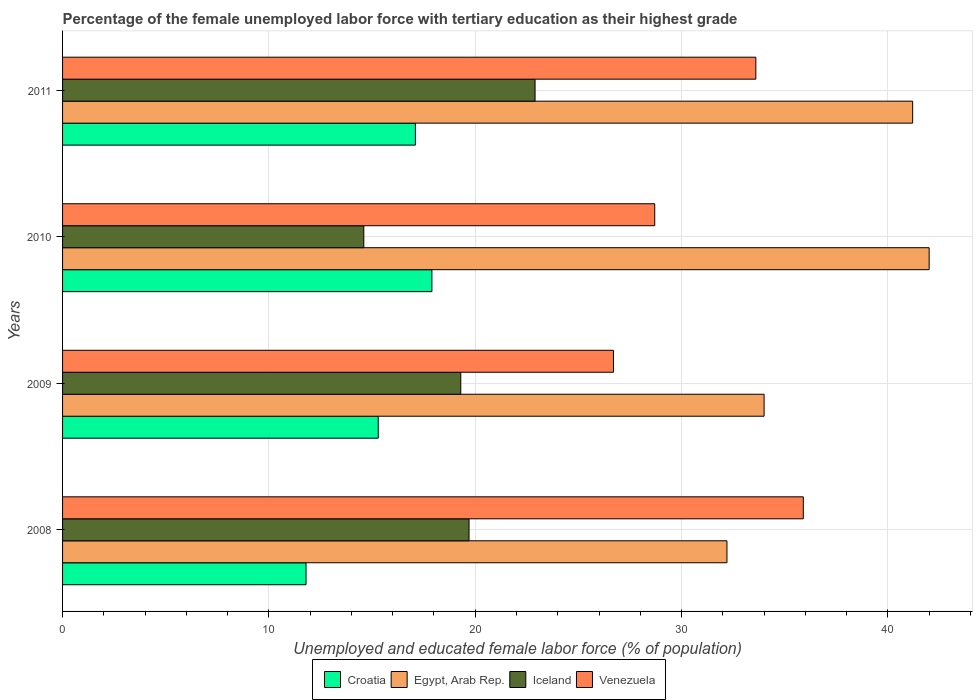Are the number of bars on each tick of the Y-axis equal?
Ensure brevity in your answer.  Yes. How many bars are there on the 2nd tick from the bottom?
Make the answer very short. 4. What is the label of the 4th group of bars from the top?
Offer a terse response. 2008. What is the percentage of the unemployed female labor force with tertiary education in Egypt, Arab Rep. in 2008?
Your response must be concise. 32.2. Across all years, what is the maximum percentage of the unemployed female labor force with tertiary education in Egypt, Arab Rep.?
Your response must be concise. 42. Across all years, what is the minimum percentage of the unemployed female labor force with tertiary education in Croatia?
Offer a very short reply. 11.8. In which year was the percentage of the unemployed female labor force with tertiary education in Egypt, Arab Rep. maximum?
Provide a short and direct response. 2010. In which year was the percentage of the unemployed female labor force with tertiary education in Egypt, Arab Rep. minimum?
Provide a succinct answer. 2008. What is the total percentage of the unemployed female labor force with tertiary education in Iceland in the graph?
Your answer should be compact. 76.5. What is the difference between the percentage of the unemployed female labor force with tertiary education in Egypt, Arab Rep. in 2009 and that in 2010?
Provide a short and direct response. -8. What is the difference between the percentage of the unemployed female labor force with tertiary education in Iceland in 2010 and the percentage of the unemployed female labor force with tertiary education in Venezuela in 2008?
Make the answer very short. -21.3. What is the average percentage of the unemployed female labor force with tertiary education in Venezuela per year?
Offer a terse response. 31.23. In the year 2011, what is the difference between the percentage of the unemployed female labor force with tertiary education in Iceland and percentage of the unemployed female labor force with tertiary education in Croatia?
Offer a very short reply. 5.8. In how many years, is the percentage of the unemployed female labor force with tertiary education in Egypt, Arab Rep. greater than 42 %?
Make the answer very short. 0. What is the ratio of the percentage of the unemployed female labor force with tertiary education in Croatia in 2008 to that in 2010?
Your answer should be compact. 0.66. Is the percentage of the unemployed female labor force with tertiary education in Croatia in 2008 less than that in 2009?
Keep it short and to the point. Yes. Is the difference between the percentage of the unemployed female labor force with tertiary education in Iceland in 2008 and 2011 greater than the difference between the percentage of the unemployed female labor force with tertiary education in Croatia in 2008 and 2011?
Your answer should be compact. Yes. What is the difference between the highest and the second highest percentage of the unemployed female labor force with tertiary education in Egypt, Arab Rep.?
Your answer should be compact. 0.8. What is the difference between the highest and the lowest percentage of the unemployed female labor force with tertiary education in Iceland?
Make the answer very short. 8.3. In how many years, is the percentage of the unemployed female labor force with tertiary education in Venezuela greater than the average percentage of the unemployed female labor force with tertiary education in Venezuela taken over all years?
Keep it short and to the point. 2. Is the sum of the percentage of the unemployed female labor force with tertiary education in Egypt, Arab Rep. in 2009 and 2011 greater than the maximum percentage of the unemployed female labor force with tertiary education in Venezuela across all years?
Offer a terse response. Yes. What does the 3rd bar from the top in 2011 represents?
Ensure brevity in your answer.  Egypt, Arab Rep. What does the 2nd bar from the bottom in 2011 represents?
Provide a short and direct response. Egypt, Arab Rep. Are all the bars in the graph horizontal?
Offer a terse response. Yes. What is the difference between two consecutive major ticks on the X-axis?
Give a very brief answer. 10. Are the values on the major ticks of X-axis written in scientific E-notation?
Ensure brevity in your answer.  No. Does the graph contain any zero values?
Make the answer very short. No. What is the title of the graph?
Your response must be concise. Percentage of the female unemployed labor force with tertiary education as their highest grade. What is the label or title of the X-axis?
Provide a short and direct response. Unemployed and educated female labor force (% of population). What is the Unemployed and educated female labor force (% of population) in Croatia in 2008?
Your answer should be very brief. 11.8. What is the Unemployed and educated female labor force (% of population) in Egypt, Arab Rep. in 2008?
Offer a terse response. 32.2. What is the Unemployed and educated female labor force (% of population) in Iceland in 2008?
Provide a succinct answer. 19.7. What is the Unemployed and educated female labor force (% of population) of Venezuela in 2008?
Provide a succinct answer. 35.9. What is the Unemployed and educated female labor force (% of population) in Croatia in 2009?
Provide a short and direct response. 15.3. What is the Unemployed and educated female labor force (% of population) of Egypt, Arab Rep. in 2009?
Ensure brevity in your answer.  34. What is the Unemployed and educated female labor force (% of population) of Iceland in 2009?
Give a very brief answer. 19.3. What is the Unemployed and educated female labor force (% of population) of Venezuela in 2009?
Your response must be concise. 26.7. What is the Unemployed and educated female labor force (% of population) of Croatia in 2010?
Offer a very short reply. 17.9. What is the Unemployed and educated female labor force (% of population) in Iceland in 2010?
Your answer should be compact. 14.6. What is the Unemployed and educated female labor force (% of population) of Venezuela in 2010?
Keep it short and to the point. 28.7. What is the Unemployed and educated female labor force (% of population) in Croatia in 2011?
Your response must be concise. 17.1. What is the Unemployed and educated female labor force (% of population) of Egypt, Arab Rep. in 2011?
Your response must be concise. 41.2. What is the Unemployed and educated female labor force (% of population) in Iceland in 2011?
Your answer should be very brief. 22.9. What is the Unemployed and educated female labor force (% of population) of Venezuela in 2011?
Your answer should be compact. 33.6. Across all years, what is the maximum Unemployed and educated female labor force (% of population) of Croatia?
Make the answer very short. 17.9. Across all years, what is the maximum Unemployed and educated female labor force (% of population) in Egypt, Arab Rep.?
Offer a terse response. 42. Across all years, what is the maximum Unemployed and educated female labor force (% of population) of Iceland?
Offer a very short reply. 22.9. Across all years, what is the maximum Unemployed and educated female labor force (% of population) in Venezuela?
Ensure brevity in your answer.  35.9. Across all years, what is the minimum Unemployed and educated female labor force (% of population) in Croatia?
Your answer should be very brief. 11.8. Across all years, what is the minimum Unemployed and educated female labor force (% of population) in Egypt, Arab Rep.?
Make the answer very short. 32.2. Across all years, what is the minimum Unemployed and educated female labor force (% of population) of Iceland?
Ensure brevity in your answer.  14.6. Across all years, what is the minimum Unemployed and educated female labor force (% of population) in Venezuela?
Your answer should be compact. 26.7. What is the total Unemployed and educated female labor force (% of population) in Croatia in the graph?
Offer a terse response. 62.1. What is the total Unemployed and educated female labor force (% of population) in Egypt, Arab Rep. in the graph?
Make the answer very short. 149.4. What is the total Unemployed and educated female labor force (% of population) in Iceland in the graph?
Keep it short and to the point. 76.5. What is the total Unemployed and educated female labor force (% of population) of Venezuela in the graph?
Offer a terse response. 124.9. What is the difference between the Unemployed and educated female labor force (% of population) in Venezuela in 2008 and that in 2009?
Keep it short and to the point. 9.2. What is the difference between the Unemployed and educated female labor force (% of population) in Egypt, Arab Rep. in 2008 and that in 2010?
Your answer should be compact. -9.8. What is the difference between the Unemployed and educated female labor force (% of population) of Iceland in 2008 and that in 2011?
Offer a very short reply. -3.2. What is the difference between the Unemployed and educated female labor force (% of population) in Venezuela in 2008 and that in 2011?
Ensure brevity in your answer.  2.3. What is the difference between the Unemployed and educated female labor force (% of population) in Croatia in 2009 and that in 2010?
Keep it short and to the point. -2.6. What is the difference between the Unemployed and educated female labor force (% of population) of Egypt, Arab Rep. in 2009 and that in 2010?
Your answer should be compact. -8. What is the difference between the Unemployed and educated female labor force (% of population) in Iceland in 2009 and that in 2010?
Keep it short and to the point. 4.7. What is the difference between the Unemployed and educated female labor force (% of population) in Venezuela in 2009 and that in 2010?
Offer a very short reply. -2. What is the difference between the Unemployed and educated female labor force (% of population) of Croatia in 2009 and that in 2011?
Your response must be concise. -1.8. What is the difference between the Unemployed and educated female labor force (% of population) of Egypt, Arab Rep. in 2009 and that in 2011?
Offer a terse response. -7.2. What is the difference between the Unemployed and educated female labor force (% of population) of Venezuela in 2009 and that in 2011?
Your answer should be very brief. -6.9. What is the difference between the Unemployed and educated female labor force (% of population) in Croatia in 2010 and that in 2011?
Offer a very short reply. 0.8. What is the difference between the Unemployed and educated female labor force (% of population) of Iceland in 2010 and that in 2011?
Provide a short and direct response. -8.3. What is the difference between the Unemployed and educated female labor force (% of population) of Croatia in 2008 and the Unemployed and educated female labor force (% of population) of Egypt, Arab Rep. in 2009?
Ensure brevity in your answer.  -22.2. What is the difference between the Unemployed and educated female labor force (% of population) in Croatia in 2008 and the Unemployed and educated female labor force (% of population) in Venezuela in 2009?
Give a very brief answer. -14.9. What is the difference between the Unemployed and educated female labor force (% of population) in Egypt, Arab Rep. in 2008 and the Unemployed and educated female labor force (% of population) in Iceland in 2009?
Your response must be concise. 12.9. What is the difference between the Unemployed and educated female labor force (% of population) of Egypt, Arab Rep. in 2008 and the Unemployed and educated female labor force (% of population) of Venezuela in 2009?
Provide a succinct answer. 5.5. What is the difference between the Unemployed and educated female labor force (% of population) in Iceland in 2008 and the Unemployed and educated female labor force (% of population) in Venezuela in 2009?
Provide a short and direct response. -7. What is the difference between the Unemployed and educated female labor force (% of population) of Croatia in 2008 and the Unemployed and educated female labor force (% of population) of Egypt, Arab Rep. in 2010?
Give a very brief answer. -30.2. What is the difference between the Unemployed and educated female labor force (% of population) of Croatia in 2008 and the Unemployed and educated female labor force (% of population) of Venezuela in 2010?
Provide a short and direct response. -16.9. What is the difference between the Unemployed and educated female labor force (% of population) of Egypt, Arab Rep. in 2008 and the Unemployed and educated female labor force (% of population) of Venezuela in 2010?
Ensure brevity in your answer.  3.5. What is the difference between the Unemployed and educated female labor force (% of population) in Iceland in 2008 and the Unemployed and educated female labor force (% of population) in Venezuela in 2010?
Offer a very short reply. -9. What is the difference between the Unemployed and educated female labor force (% of population) of Croatia in 2008 and the Unemployed and educated female labor force (% of population) of Egypt, Arab Rep. in 2011?
Offer a very short reply. -29.4. What is the difference between the Unemployed and educated female labor force (% of population) of Croatia in 2008 and the Unemployed and educated female labor force (% of population) of Venezuela in 2011?
Provide a succinct answer. -21.8. What is the difference between the Unemployed and educated female labor force (% of population) in Egypt, Arab Rep. in 2008 and the Unemployed and educated female labor force (% of population) in Venezuela in 2011?
Your answer should be very brief. -1.4. What is the difference between the Unemployed and educated female labor force (% of population) of Iceland in 2008 and the Unemployed and educated female labor force (% of population) of Venezuela in 2011?
Ensure brevity in your answer.  -13.9. What is the difference between the Unemployed and educated female labor force (% of population) of Croatia in 2009 and the Unemployed and educated female labor force (% of population) of Egypt, Arab Rep. in 2010?
Your answer should be very brief. -26.7. What is the difference between the Unemployed and educated female labor force (% of population) in Egypt, Arab Rep. in 2009 and the Unemployed and educated female labor force (% of population) in Iceland in 2010?
Give a very brief answer. 19.4. What is the difference between the Unemployed and educated female labor force (% of population) of Croatia in 2009 and the Unemployed and educated female labor force (% of population) of Egypt, Arab Rep. in 2011?
Your answer should be very brief. -25.9. What is the difference between the Unemployed and educated female labor force (% of population) of Croatia in 2009 and the Unemployed and educated female labor force (% of population) of Venezuela in 2011?
Your answer should be compact. -18.3. What is the difference between the Unemployed and educated female labor force (% of population) of Iceland in 2009 and the Unemployed and educated female labor force (% of population) of Venezuela in 2011?
Offer a terse response. -14.3. What is the difference between the Unemployed and educated female labor force (% of population) of Croatia in 2010 and the Unemployed and educated female labor force (% of population) of Egypt, Arab Rep. in 2011?
Give a very brief answer. -23.3. What is the difference between the Unemployed and educated female labor force (% of population) of Croatia in 2010 and the Unemployed and educated female labor force (% of population) of Venezuela in 2011?
Provide a succinct answer. -15.7. What is the difference between the Unemployed and educated female labor force (% of population) of Egypt, Arab Rep. in 2010 and the Unemployed and educated female labor force (% of population) of Iceland in 2011?
Your answer should be very brief. 19.1. What is the difference between the Unemployed and educated female labor force (% of population) in Egypt, Arab Rep. in 2010 and the Unemployed and educated female labor force (% of population) in Venezuela in 2011?
Offer a very short reply. 8.4. What is the average Unemployed and educated female labor force (% of population) of Croatia per year?
Ensure brevity in your answer.  15.53. What is the average Unemployed and educated female labor force (% of population) in Egypt, Arab Rep. per year?
Keep it short and to the point. 37.35. What is the average Unemployed and educated female labor force (% of population) in Iceland per year?
Offer a very short reply. 19.12. What is the average Unemployed and educated female labor force (% of population) of Venezuela per year?
Ensure brevity in your answer.  31.23. In the year 2008, what is the difference between the Unemployed and educated female labor force (% of population) of Croatia and Unemployed and educated female labor force (% of population) of Egypt, Arab Rep.?
Your answer should be compact. -20.4. In the year 2008, what is the difference between the Unemployed and educated female labor force (% of population) of Croatia and Unemployed and educated female labor force (% of population) of Iceland?
Ensure brevity in your answer.  -7.9. In the year 2008, what is the difference between the Unemployed and educated female labor force (% of population) in Croatia and Unemployed and educated female labor force (% of population) in Venezuela?
Ensure brevity in your answer.  -24.1. In the year 2008, what is the difference between the Unemployed and educated female labor force (% of population) in Egypt, Arab Rep. and Unemployed and educated female labor force (% of population) in Iceland?
Provide a succinct answer. 12.5. In the year 2008, what is the difference between the Unemployed and educated female labor force (% of population) in Iceland and Unemployed and educated female labor force (% of population) in Venezuela?
Ensure brevity in your answer.  -16.2. In the year 2009, what is the difference between the Unemployed and educated female labor force (% of population) in Croatia and Unemployed and educated female labor force (% of population) in Egypt, Arab Rep.?
Your response must be concise. -18.7. In the year 2009, what is the difference between the Unemployed and educated female labor force (% of population) in Croatia and Unemployed and educated female labor force (% of population) in Iceland?
Provide a short and direct response. -4. In the year 2009, what is the difference between the Unemployed and educated female labor force (% of population) of Iceland and Unemployed and educated female labor force (% of population) of Venezuela?
Make the answer very short. -7.4. In the year 2010, what is the difference between the Unemployed and educated female labor force (% of population) in Croatia and Unemployed and educated female labor force (% of population) in Egypt, Arab Rep.?
Ensure brevity in your answer.  -24.1. In the year 2010, what is the difference between the Unemployed and educated female labor force (% of population) of Egypt, Arab Rep. and Unemployed and educated female labor force (% of population) of Iceland?
Give a very brief answer. 27.4. In the year 2010, what is the difference between the Unemployed and educated female labor force (% of population) of Egypt, Arab Rep. and Unemployed and educated female labor force (% of population) of Venezuela?
Offer a terse response. 13.3. In the year 2010, what is the difference between the Unemployed and educated female labor force (% of population) of Iceland and Unemployed and educated female labor force (% of population) of Venezuela?
Your response must be concise. -14.1. In the year 2011, what is the difference between the Unemployed and educated female labor force (% of population) in Croatia and Unemployed and educated female labor force (% of population) in Egypt, Arab Rep.?
Your response must be concise. -24.1. In the year 2011, what is the difference between the Unemployed and educated female labor force (% of population) in Croatia and Unemployed and educated female labor force (% of population) in Venezuela?
Ensure brevity in your answer.  -16.5. In the year 2011, what is the difference between the Unemployed and educated female labor force (% of population) of Egypt, Arab Rep. and Unemployed and educated female labor force (% of population) of Venezuela?
Keep it short and to the point. 7.6. What is the ratio of the Unemployed and educated female labor force (% of population) in Croatia in 2008 to that in 2009?
Provide a short and direct response. 0.77. What is the ratio of the Unemployed and educated female labor force (% of population) of Egypt, Arab Rep. in 2008 to that in 2009?
Give a very brief answer. 0.95. What is the ratio of the Unemployed and educated female labor force (% of population) in Iceland in 2008 to that in 2009?
Ensure brevity in your answer.  1.02. What is the ratio of the Unemployed and educated female labor force (% of population) in Venezuela in 2008 to that in 2009?
Ensure brevity in your answer.  1.34. What is the ratio of the Unemployed and educated female labor force (% of population) of Croatia in 2008 to that in 2010?
Keep it short and to the point. 0.66. What is the ratio of the Unemployed and educated female labor force (% of population) of Egypt, Arab Rep. in 2008 to that in 2010?
Provide a succinct answer. 0.77. What is the ratio of the Unemployed and educated female labor force (% of population) in Iceland in 2008 to that in 2010?
Provide a short and direct response. 1.35. What is the ratio of the Unemployed and educated female labor force (% of population) of Venezuela in 2008 to that in 2010?
Your answer should be very brief. 1.25. What is the ratio of the Unemployed and educated female labor force (% of population) in Croatia in 2008 to that in 2011?
Make the answer very short. 0.69. What is the ratio of the Unemployed and educated female labor force (% of population) in Egypt, Arab Rep. in 2008 to that in 2011?
Provide a succinct answer. 0.78. What is the ratio of the Unemployed and educated female labor force (% of population) in Iceland in 2008 to that in 2011?
Keep it short and to the point. 0.86. What is the ratio of the Unemployed and educated female labor force (% of population) in Venezuela in 2008 to that in 2011?
Ensure brevity in your answer.  1.07. What is the ratio of the Unemployed and educated female labor force (% of population) of Croatia in 2009 to that in 2010?
Your answer should be very brief. 0.85. What is the ratio of the Unemployed and educated female labor force (% of population) in Egypt, Arab Rep. in 2009 to that in 2010?
Ensure brevity in your answer.  0.81. What is the ratio of the Unemployed and educated female labor force (% of population) in Iceland in 2009 to that in 2010?
Make the answer very short. 1.32. What is the ratio of the Unemployed and educated female labor force (% of population) of Venezuela in 2009 to that in 2010?
Your response must be concise. 0.93. What is the ratio of the Unemployed and educated female labor force (% of population) of Croatia in 2009 to that in 2011?
Make the answer very short. 0.89. What is the ratio of the Unemployed and educated female labor force (% of population) of Egypt, Arab Rep. in 2009 to that in 2011?
Give a very brief answer. 0.83. What is the ratio of the Unemployed and educated female labor force (% of population) in Iceland in 2009 to that in 2011?
Offer a terse response. 0.84. What is the ratio of the Unemployed and educated female labor force (% of population) of Venezuela in 2009 to that in 2011?
Provide a succinct answer. 0.79. What is the ratio of the Unemployed and educated female labor force (% of population) in Croatia in 2010 to that in 2011?
Give a very brief answer. 1.05. What is the ratio of the Unemployed and educated female labor force (% of population) of Egypt, Arab Rep. in 2010 to that in 2011?
Your answer should be compact. 1.02. What is the ratio of the Unemployed and educated female labor force (% of population) in Iceland in 2010 to that in 2011?
Provide a short and direct response. 0.64. What is the ratio of the Unemployed and educated female labor force (% of population) in Venezuela in 2010 to that in 2011?
Offer a very short reply. 0.85. What is the difference between the highest and the second highest Unemployed and educated female labor force (% of population) in Croatia?
Your answer should be very brief. 0.8. What is the difference between the highest and the second highest Unemployed and educated female labor force (% of population) of Iceland?
Offer a very short reply. 3.2. What is the difference between the highest and the second highest Unemployed and educated female labor force (% of population) of Venezuela?
Offer a very short reply. 2.3. What is the difference between the highest and the lowest Unemployed and educated female labor force (% of population) of Iceland?
Keep it short and to the point. 8.3. 